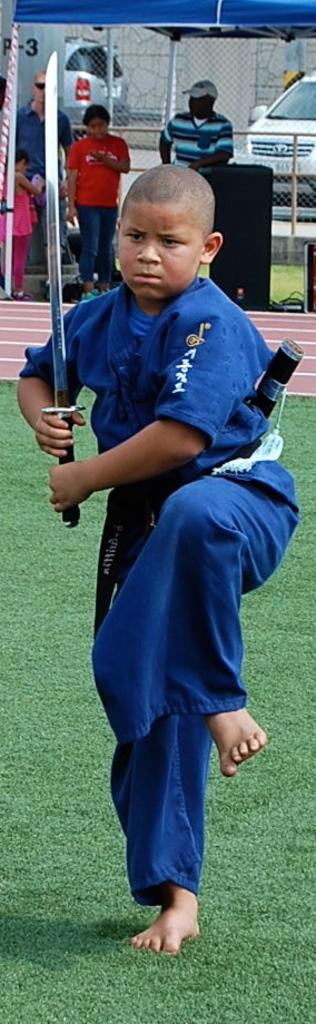Who is the main subject in the image? There is a boy in the image. What is the boy holding in the image? The boy is holding a sword. What can be seen in the background of the image? There are people under a tent and cars in the background of the image. How many kittens are playing on the bed in the image? There are no kittens or beds present in the image. Can you describe the wave that is visible in the image? There is no wave visible in the image. 